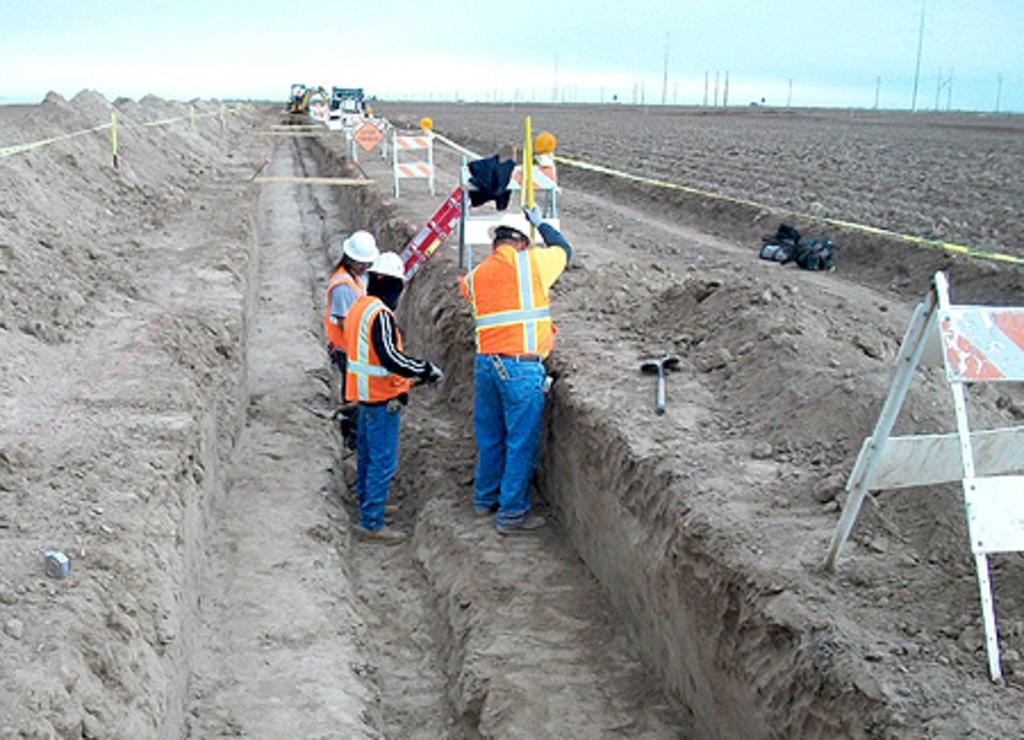Describe this image in one or two sentences. This is an outside view. In the middle of the image three persons are wearing jackets, caps on their heads and standing on the ground. They are looking at the downwards. On the right side, I can see some boards are placed on the ground and also I can see a black color object. In the background there are many poles. At the top of the image I can see the sky. 